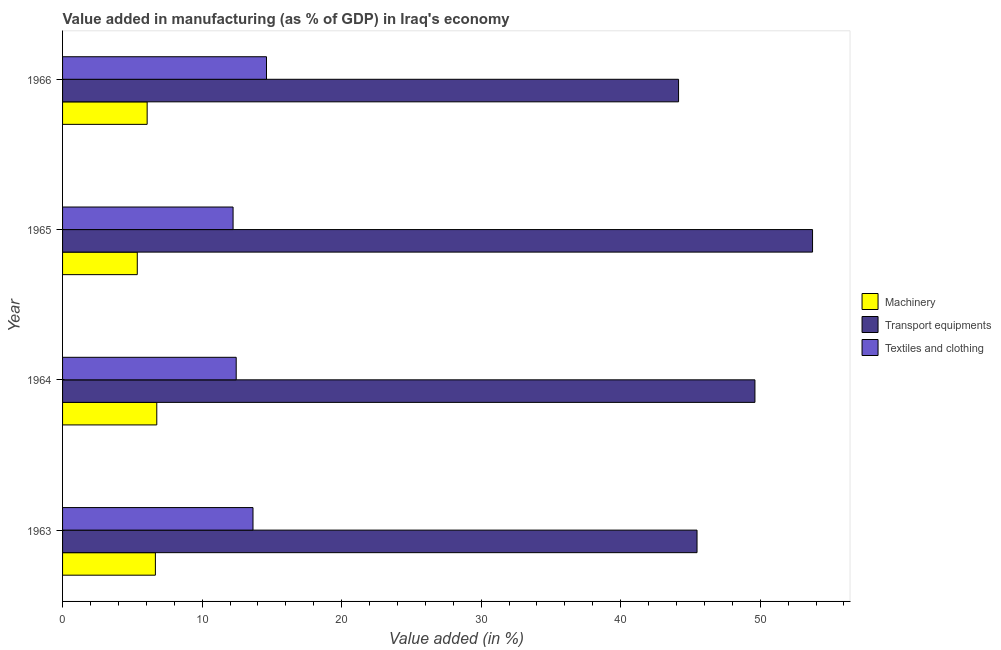How many groups of bars are there?
Your response must be concise. 4. How many bars are there on the 3rd tick from the top?
Provide a short and direct response. 3. What is the label of the 3rd group of bars from the top?
Keep it short and to the point. 1964. In how many cases, is the number of bars for a given year not equal to the number of legend labels?
Give a very brief answer. 0. What is the value added in manufacturing machinery in 1963?
Your answer should be very brief. 6.65. Across all years, what is the maximum value added in manufacturing machinery?
Provide a succinct answer. 6.75. Across all years, what is the minimum value added in manufacturing transport equipments?
Your response must be concise. 44.15. In which year was the value added in manufacturing machinery maximum?
Ensure brevity in your answer.  1964. In which year was the value added in manufacturing textile and clothing minimum?
Your response must be concise. 1965. What is the total value added in manufacturing transport equipments in the graph?
Your response must be concise. 193. What is the difference between the value added in manufacturing machinery in 1963 and that in 1966?
Ensure brevity in your answer.  0.59. What is the difference between the value added in manufacturing transport equipments in 1966 and the value added in manufacturing machinery in 1964?
Your response must be concise. 37.4. What is the average value added in manufacturing textile and clothing per year?
Ensure brevity in your answer.  13.23. In the year 1964, what is the difference between the value added in manufacturing machinery and value added in manufacturing textile and clothing?
Keep it short and to the point. -5.69. In how many years, is the value added in manufacturing machinery greater than 16 %?
Provide a succinct answer. 0. What is the ratio of the value added in manufacturing transport equipments in 1963 to that in 1966?
Make the answer very short. 1.03. Is the value added in manufacturing machinery in 1963 less than that in 1966?
Provide a succinct answer. No. What is the difference between the highest and the second highest value added in manufacturing transport equipments?
Your answer should be very brief. 4.13. In how many years, is the value added in manufacturing transport equipments greater than the average value added in manufacturing transport equipments taken over all years?
Offer a very short reply. 2. What does the 1st bar from the top in 1965 represents?
Offer a very short reply. Textiles and clothing. What does the 1st bar from the bottom in 1963 represents?
Your answer should be compact. Machinery. Are the values on the major ticks of X-axis written in scientific E-notation?
Keep it short and to the point. No. Does the graph contain grids?
Give a very brief answer. No. Where does the legend appear in the graph?
Ensure brevity in your answer.  Center right. How many legend labels are there?
Make the answer very short. 3. What is the title of the graph?
Provide a succinct answer. Value added in manufacturing (as % of GDP) in Iraq's economy. Does "Taxes" appear as one of the legend labels in the graph?
Your answer should be very brief. No. What is the label or title of the X-axis?
Offer a terse response. Value added (in %). What is the label or title of the Y-axis?
Keep it short and to the point. Year. What is the Value added (in %) of Machinery in 1963?
Make the answer very short. 6.65. What is the Value added (in %) in Transport equipments in 1963?
Provide a succinct answer. 45.47. What is the Value added (in %) in Textiles and clothing in 1963?
Offer a very short reply. 13.65. What is the Value added (in %) in Machinery in 1964?
Make the answer very short. 6.75. What is the Value added (in %) of Transport equipments in 1964?
Give a very brief answer. 49.62. What is the Value added (in %) of Textiles and clothing in 1964?
Make the answer very short. 12.44. What is the Value added (in %) of Machinery in 1965?
Offer a very short reply. 5.36. What is the Value added (in %) of Transport equipments in 1965?
Provide a short and direct response. 53.75. What is the Value added (in %) in Textiles and clothing in 1965?
Provide a succinct answer. 12.22. What is the Value added (in %) in Machinery in 1966?
Your answer should be compact. 6.06. What is the Value added (in %) in Transport equipments in 1966?
Your answer should be very brief. 44.15. What is the Value added (in %) in Textiles and clothing in 1966?
Provide a succinct answer. 14.62. Across all years, what is the maximum Value added (in %) of Machinery?
Give a very brief answer. 6.75. Across all years, what is the maximum Value added (in %) of Transport equipments?
Provide a short and direct response. 53.75. Across all years, what is the maximum Value added (in %) of Textiles and clothing?
Offer a very short reply. 14.62. Across all years, what is the minimum Value added (in %) of Machinery?
Provide a short and direct response. 5.36. Across all years, what is the minimum Value added (in %) in Transport equipments?
Your response must be concise. 44.15. Across all years, what is the minimum Value added (in %) in Textiles and clothing?
Make the answer very short. 12.22. What is the total Value added (in %) of Machinery in the graph?
Make the answer very short. 24.82. What is the total Value added (in %) in Transport equipments in the graph?
Your response must be concise. 193. What is the total Value added (in %) in Textiles and clothing in the graph?
Your answer should be very brief. 52.93. What is the difference between the Value added (in %) of Machinery in 1963 and that in 1964?
Your answer should be very brief. -0.1. What is the difference between the Value added (in %) in Transport equipments in 1963 and that in 1964?
Your answer should be compact. -4.15. What is the difference between the Value added (in %) of Textiles and clothing in 1963 and that in 1964?
Provide a short and direct response. 1.2. What is the difference between the Value added (in %) of Machinery in 1963 and that in 1965?
Give a very brief answer. 1.3. What is the difference between the Value added (in %) in Transport equipments in 1963 and that in 1965?
Your answer should be compact. -8.28. What is the difference between the Value added (in %) in Textiles and clothing in 1963 and that in 1965?
Offer a very short reply. 1.43. What is the difference between the Value added (in %) of Machinery in 1963 and that in 1966?
Provide a short and direct response. 0.59. What is the difference between the Value added (in %) in Transport equipments in 1963 and that in 1966?
Give a very brief answer. 1.32. What is the difference between the Value added (in %) of Textiles and clothing in 1963 and that in 1966?
Provide a succinct answer. -0.97. What is the difference between the Value added (in %) of Machinery in 1964 and that in 1965?
Provide a short and direct response. 1.4. What is the difference between the Value added (in %) in Transport equipments in 1964 and that in 1965?
Your answer should be very brief. -4.13. What is the difference between the Value added (in %) in Textiles and clothing in 1964 and that in 1965?
Your answer should be compact. 0.22. What is the difference between the Value added (in %) in Machinery in 1964 and that in 1966?
Your response must be concise. 0.69. What is the difference between the Value added (in %) of Transport equipments in 1964 and that in 1966?
Offer a very short reply. 5.47. What is the difference between the Value added (in %) of Textiles and clothing in 1964 and that in 1966?
Your answer should be very brief. -2.17. What is the difference between the Value added (in %) of Machinery in 1965 and that in 1966?
Make the answer very short. -0.71. What is the difference between the Value added (in %) in Transport equipments in 1965 and that in 1966?
Provide a short and direct response. 9.6. What is the difference between the Value added (in %) of Textiles and clothing in 1965 and that in 1966?
Ensure brevity in your answer.  -2.4. What is the difference between the Value added (in %) of Machinery in 1963 and the Value added (in %) of Transport equipments in 1964?
Give a very brief answer. -42.97. What is the difference between the Value added (in %) of Machinery in 1963 and the Value added (in %) of Textiles and clothing in 1964?
Make the answer very short. -5.79. What is the difference between the Value added (in %) of Transport equipments in 1963 and the Value added (in %) of Textiles and clothing in 1964?
Ensure brevity in your answer.  33.03. What is the difference between the Value added (in %) in Machinery in 1963 and the Value added (in %) in Transport equipments in 1965?
Keep it short and to the point. -47.1. What is the difference between the Value added (in %) in Machinery in 1963 and the Value added (in %) in Textiles and clothing in 1965?
Offer a terse response. -5.57. What is the difference between the Value added (in %) in Transport equipments in 1963 and the Value added (in %) in Textiles and clothing in 1965?
Offer a very short reply. 33.25. What is the difference between the Value added (in %) in Machinery in 1963 and the Value added (in %) in Transport equipments in 1966?
Give a very brief answer. -37.5. What is the difference between the Value added (in %) of Machinery in 1963 and the Value added (in %) of Textiles and clothing in 1966?
Provide a succinct answer. -7.96. What is the difference between the Value added (in %) in Transport equipments in 1963 and the Value added (in %) in Textiles and clothing in 1966?
Your response must be concise. 30.86. What is the difference between the Value added (in %) in Machinery in 1964 and the Value added (in %) in Transport equipments in 1965?
Ensure brevity in your answer.  -47. What is the difference between the Value added (in %) of Machinery in 1964 and the Value added (in %) of Textiles and clothing in 1965?
Your response must be concise. -5.47. What is the difference between the Value added (in %) in Transport equipments in 1964 and the Value added (in %) in Textiles and clothing in 1965?
Ensure brevity in your answer.  37.4. What is the difference between the Value added (in %) of Machinery in 1964 and the Value added (in %) of Transport equipments in 1966?
Give a very brief answer. -37.4. What is the difference between the Value added (in %) in Machinery in 1964 and the Value added (in %) in Textiles and clothing in 1966?
Offer a very short reply. -7.86. What is the difference between the Value added (in %) in Transport equipments in 1964 and the Value added (in %) in Textiles and clothing in 1966?
Your response must be concise. 35.01. What is the difference between the Value added (in %) in Machinery in 1965 and the Value added (in %) in Transport equipments in 1966?
Provide a short and direct response. -38.79. What is the difference between the Value added (in %) of Machinery in 1965 and the Value added (in %) of Textiles and clothing in 1966?
Offer a very short reply. -9.26. What is the difference between the Value added (in %) in Transport equipments in 1965 and the Value added (in %) in Textiles and clothing in 1966?
Give a very brief answer. 39.14. What is the average Value added (in %) of Machinery per year?
Provide a succinct answer. 6.21. What is the average Value added (in %) in Transport equipments per year?
Provide a short and direct response. 48.25. What is the average Value added (in %) in Textiles and clothing per year?
Ensure brevity in your answer.  13.23. In the year 1963, what is the difference between the Value added (in %) in Machinery and Value added (in %) in Transport equipments?
Ensure brevity in your answer.  -38.82. In the year 1963, what is the difference between the Value added (in %) of Machinery and Value added (in %) of Textiles and clothing?
Ensure brevity in your answer.  -7. In the year 1963, what is the difference between the Value added (in %) in Transport equipments and Value added (in %) in Textiles and clothing?
Offer a very short reply. 31.82. In the year 1964, what is the difference between the Value added (in %) in Machinery and Value added (in %) in Transport equipments?
Your answer should be compact. -42.87. In the year 1964, what is the difference between the Value added (in %) of Machinery and Value added (in %) of Textiles and clothing?
Make the answer very short. -5.69. In the year 1964, what is the difference between the Value added (in %) of Transport equipments and Value added (in %) of Textiles and clothing?
Provide a short and direct response. 37.18. In the year 1965, what is the difference between the Value added (in %) of Machinery and Value added (in %) of Transport equipments?
Offer a very short reply. -48.4. In the year 1965, what is the difference between the Value added (in %) of Machinery and Value added (in %) of Textiles and clothing?
Give a very brief answer. -6.87. In the year 1965, what is the difference between the Value added (in %) in Transport equipments and Value added (in %) in Textiles and clothing?
Offer a terse response. 41.53. In the year 1966, what is the difference between the Value added (in %) of Machinery and Value added (in %) of Transport equipments?
Provide a short and direct response. -38.09. In the year 1966, what is the difference between the Value added (in %) of Machinery and Value added (in %) of Textiles and clothing?
Offer a very short reply. -8.55. In the year 1966, what is the difference between the Value added (in %) of Transport equipments and Value added (in %) of Textiles and clothing?
Your answer should be compact. 29.53. What is the ratio of the Value added (in %) of Machinery in 1963 to that in 1964?
Offer a terse response. 0.99. What is the ratio of the Value added (in %) of Transport equipments in 1963 to that in 1964?
Keep it short and to the point. 0.92. What is the ratio of the Value added (in %) in Textiles and clothing in 1963 to that in 1964?
Make the answer very short. 1.1. What is the ratio of the Value added (in %) in Machinery in 1963 to that in 1965?
Your answer should be very brief. 1.24. What is the ratio of the Value added (in %) in Transport equipments in 1963 to that in 1965?
Provide a short and direct response. 0.85. What is the ratio of the Value added (in %) in Textiles and clothing in 1963 to that in 1965?
Give a very brief answer. 1.12. What is the ratio of the Value added (in %) in Machinery in 1963 to that in 1966?
Offer a terse response. 1.1. What is the ratio of the Value added (in %) in Textiles and clothing in 1963 to that in 1966?
Offer a very short reply. 0.93. What is the ratio of the Value added (in %) in Machinery in 1964 to that in 1965?
Your response must be concise. 1.26. What is the ratio of the Value added (in %) in Transport equipments in 1964 to that in 1965?
Ensure brevity in your answer.  0.92. What is the ratio of the Value added (in %) of Textiles and clothing in 1964 to that in 1965?
Give a very brief answer. 1.02. What is the ratio of the Value added (in %) of Machinery in 1964 to that in 1966?
Your answer should be compact. 1.11. What is the ratio of the Value added (in %) of Transport equipments in 1964 to that in 1966?
Ensure brevity in your answer.  1.12. What is the ratio of the Value added (in %) of Textiles and clothing in 1964 to that in 1966?
Ensure brevity in your answer.  0.85. What is the ratio of the Value added (in %) of Machinery in 1965 to that in 1966?
Your answer should be compact. 0.88. What is the ratio of the Value added (in %) in Transport equipments in 1965 to that in 1966?
Offer a terse response. 1.22. What is the ratio of the Value added (in %) in Textiles and clothing in 1965 to that in 1966?
Keep it short and to the point. 0.84. What is the difference between the highest and the second highest Value added (in %) of Machinery?
Offer a terse response. 0.1. What is the difference between the highest and the second highest Value added (in %) in Transport equipments?
Your response must be concise. 4.13. What is the difference between the highest and the second highest Value added (in %) of Textiles and clothing?
Provide a succinct answer. 0.97. What is the difference between the highest and the lowest Value added (in %) of Machinery?
Keep it short and to the point. 1.4. What is the difference between the highest and the lowest Value added (in %) of Transport equipments?
Offer a very short reply. 9.6. What is the difference between the highest and the lowest Value added (in %) in Textiles and clothing?
Ensure brevity in your answer.  2.4. 